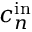Convert formula to latex. <formula><loc_0><loc_0><loc_500><loc_500>c _ { n } ^ { i n }</formula> 